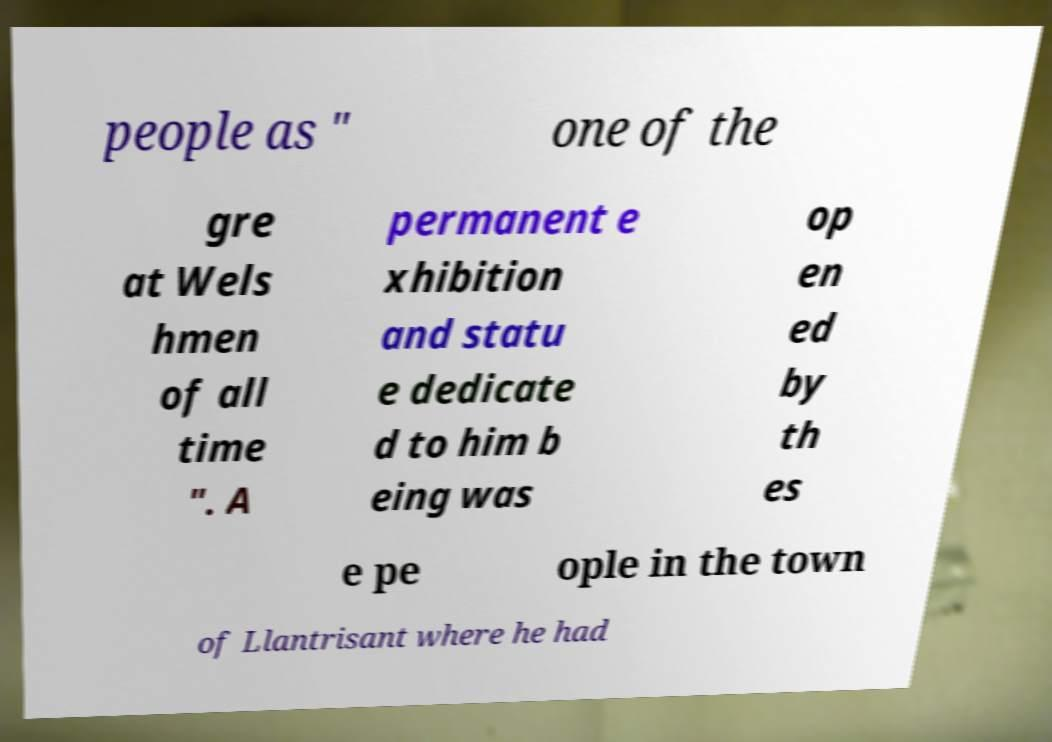Please read and relay the text visible in this image. What does it say? people as " one of the gre at Wels hmen of all time ". A permanent e xhibition and statu e dedicate d to him b eing was op en ed by th es e pe ople in the town of Llantrisant where he had 